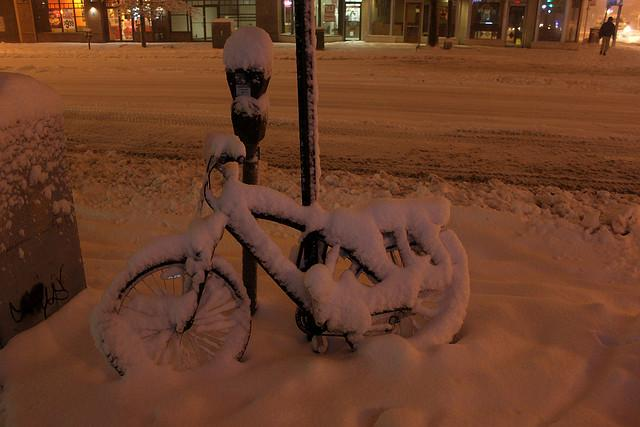How much did the owner of this bike put into the parking meter here? Please explain your reasoning. none. There seemed to be a snow storm and the bike was left on the meter since it is covered in layers of snow. therefore there is no way the owner left any time on the meter. 